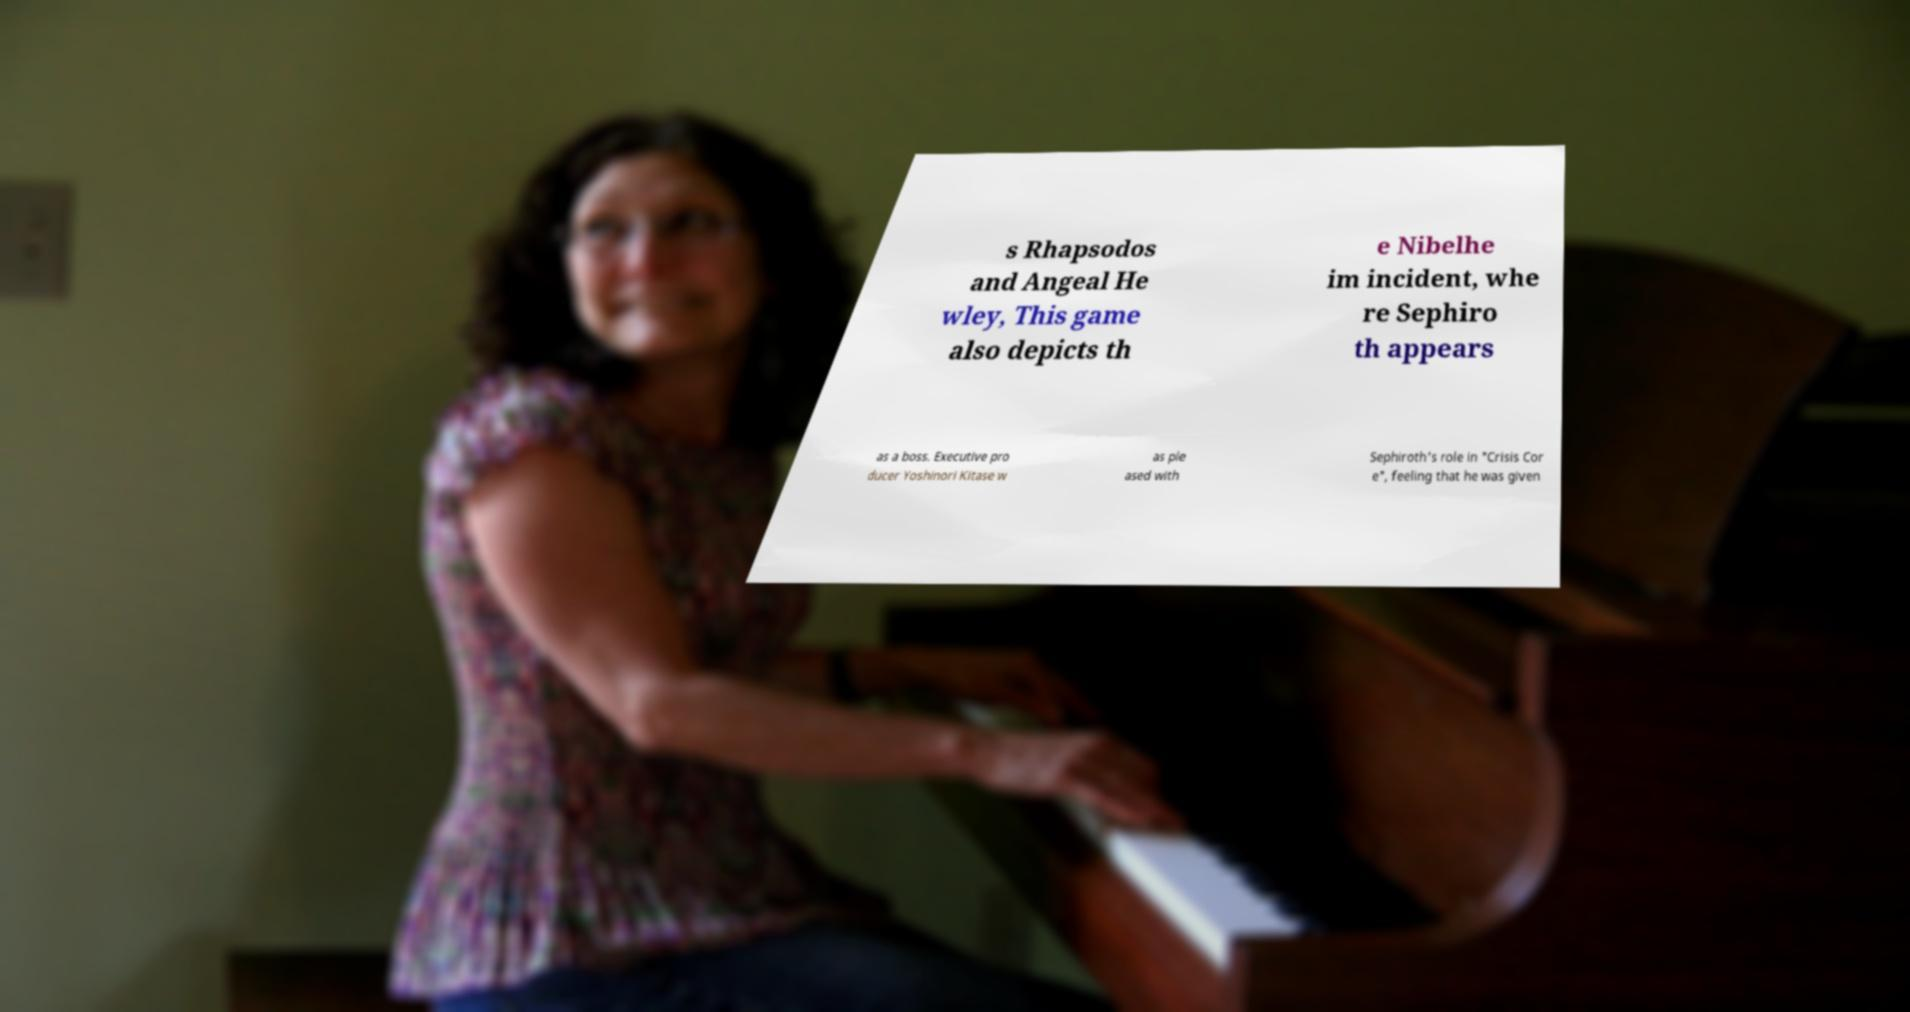For documentation purposes, I need the text within this image transcribed. Could you provide that? s Rhapsodos and Angeal He wley, This game also depicts th e Nibelhe im incident, whe re Sephiro th appears as a boss. Executive pro ducer Yoshinori Kitase w as ple ased with Sephiroth's role in "Crisis Cor e", feeling that he was given 